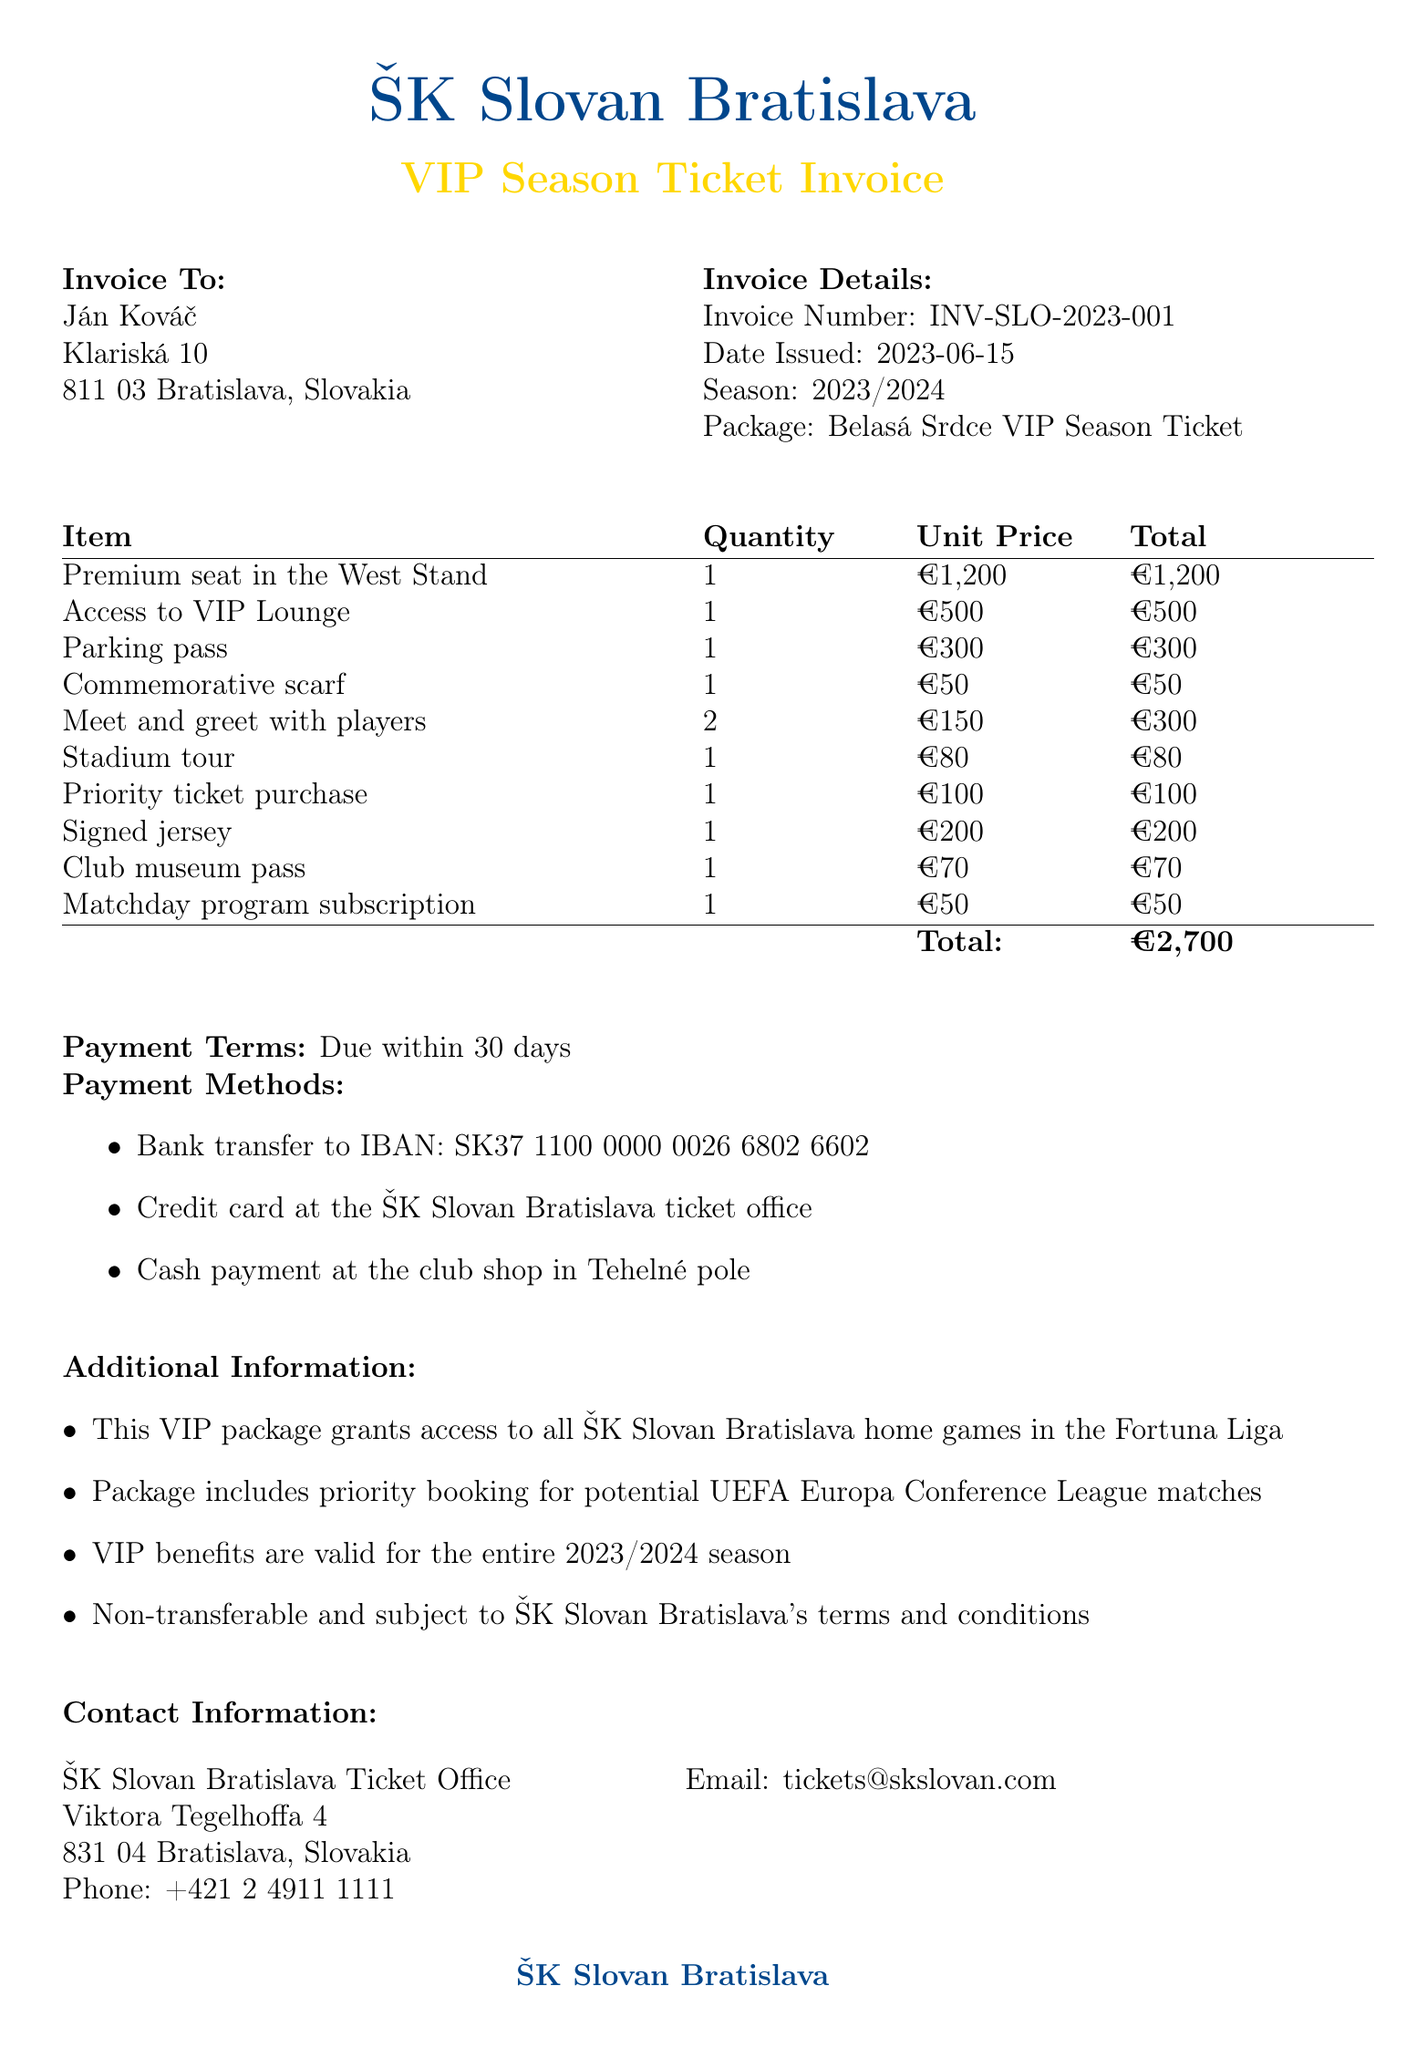What is the invoice number? The invoice number is specified in the document under Invoice Details.
Answer: INV-SLO-2023-001 Who is the customer? The customer's name is listed at the top of the invoice.
Answer: Ján Kováč What is the total price for the VIP package? The total price is clearly indicated in the itemized table at the bottom of the document.
Answer: €2,700 When was the invoice issued? The date issued is mentioned prominently in the Invoice Details section.
Answer: 2023-06-15 How many meet and greet sessions are included? The number of sessions is stated in the package items list.
Answer: 2 What is one of the payment methods? Various payment methods are listed, allowing for multiple possible answers.
Answer: Bank transfer to IBAN: SK37 1100 0000 0026 6802 6602 What kind of seat is included with the package? The type of seat is noted in the package items section.
Answer: Premium seat in the West Stand Is the VIP package transferable? Transferability is addressed in the additional information section.
Answer: Non-transferable What is the name of the ticket office? The ticket office name is part of the contact information provided at the bottom of the document.
Answer: ŠK Slovan Bratislava Ticket Office 